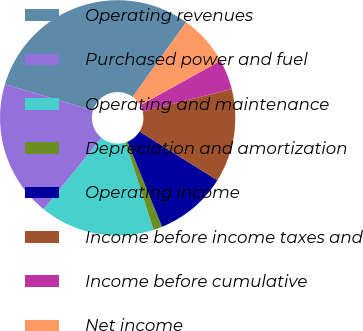Convert chart. <chart><loc_0><loc_0><loc_500><loc_500><pie_chart><fcel>Operating revenues<fcel>Purchased power and fuel<fcel>Operating and maintenance<fcel>Depreciation and amortization<fcel>Operating income<fcel>Income before income taxes and<fcel>Income before cumulative<fcel>Net income<nl><fcel>30.29%<fcel>18.79%<fcel>15.76%<fcel>1.22%<fcel>9.94%<fcel>12.85%<fcel>4.13%<fcel>7.03%<nl></chart> 